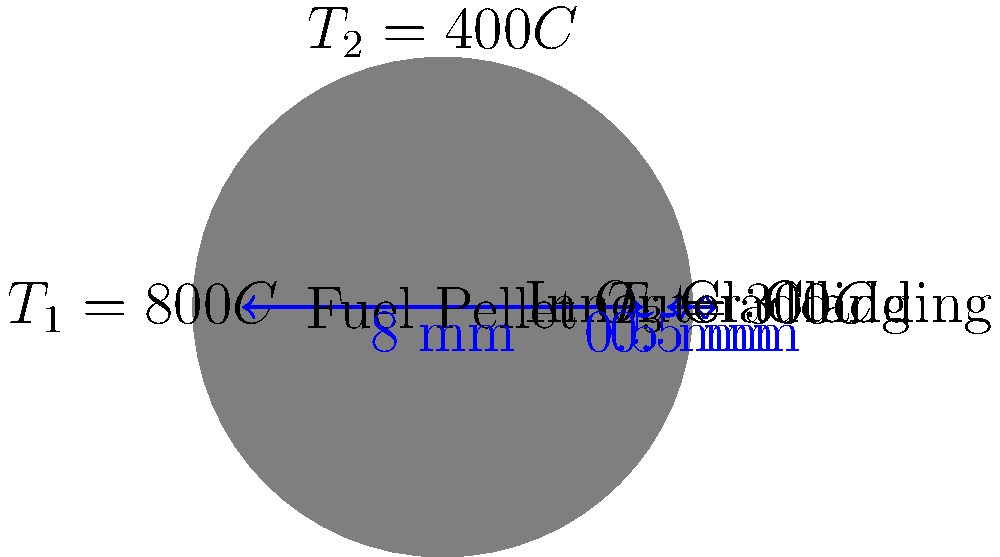A nuclear fuel rod consists of a fuel pellet surrounded by two layers of cladding. The fuel pellet has a diameter of 8 mm, and each cladding layer is 0.5 mm thick. The temperature at the center of the fuel pellet is 800°C, the temperature at the interface between the inner and outer cladding is 400°C, and the temperature at the outer surface of the cladding is 300°C. Calculate the total thermal resistance of the cladding layers if the thermal conductivity of the inner cladding is 15 W/m·K and the outer cladding is 20 W/m·K. To calculate the total thermal resistance of the cladding layers, we'll follow these steps:

1) The thermal resistance for a cylindrical layer is given by:
   $$R = \frac{\ln(r_2/r_1)}{2\pi k L}$$
   where $r_2$ is the outer radius, $r_1$ is the inner radius, $k$ is the thermal conductivity, and $L$ is the length of the cylinder.

2) For the inner cladding:
   $r_1 = 4$ mm, $r_2 = 4.5$ mm, $k = 15$ W/m·K
   $$R_1 = \frac{\ln(4.5/4)}{2\pi \cdot 15 \cdot L} = \frac{0.1178}{94.25L}$$

3) For the outer cladding:
   $r_1 = 4.5$ mm, $r_2 = 5$ mm, $k = 20$ W/m·K
   $$R_2 = \frac{\ln(5/4.5)}{2\pi \cdot 20 \cdot L} = \frac{0.1054}{125.66L}$$

4) The total resistance is the sum of these two resistances:
   $$R_{total} = R_1 + R_2 = \frac{0.1178}{94.25L} + \frac{0.1054}{125.66L} = \frac{0.002084}{L}$$

5) Note that $L$ cancels out in the final result, meaning the total resistance per unit length is $0.002084$ m·K/W.
Answer: $0.002084$ m·K/W 